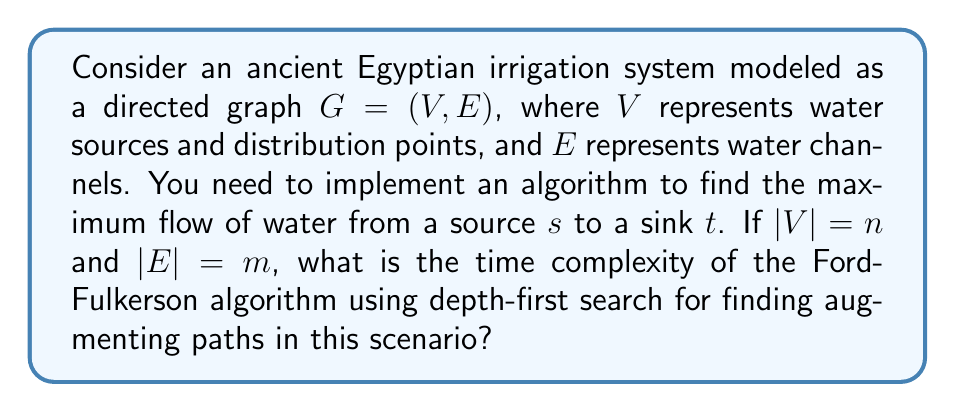Teach me how to tackle this problem. To analyze the time complexity of the Ford-Fulkerson algorithm for this ancient irrigation system, we need to consider the following steps:

1) The Ford-Fulkerson algorithm iteratively finds augmenting paths and updates the flow until no more augmenting paths exist.

2) In the worst case, each augmenting path might increase the flow by only 1 unit. Let's denote the maximum flow as $f$.

3) For each iteration:
   a) We use depth-first search (DFS) to find an augmenting path.
   b) DFS takes $O(|V| + |E|) = O(n + m)$ time.

4) The number of iterations is bounded by the maximum flow $f$.

5) Therefore, the total time complexity is $O(f(n + m))$.

6) However, in the context of an ancient irrigation system, we need to consider the practical limitations of water flow. The maximum flow $f$ would typically be bounded by the capacity of the channels, which we can assume to be represented by integers not exceeding a constant $C$.

7) With this assumption, the time complexity becomes $O(C(n + m))$.

8) Since $C$ is a constant, we can simplify this to $O(n + m)$.

This analysis shows that for practical ancient irrigation systems with bounded channel capacities, the Ford-Fulkerson algorithm has a linear time complexity in terms of the number of vertices and edges in the graph.
Answer: $O(n + m)$, where $n$ is the number of vertices and $m$ is the number of edges in the graph representing the ancient irrigation system. 